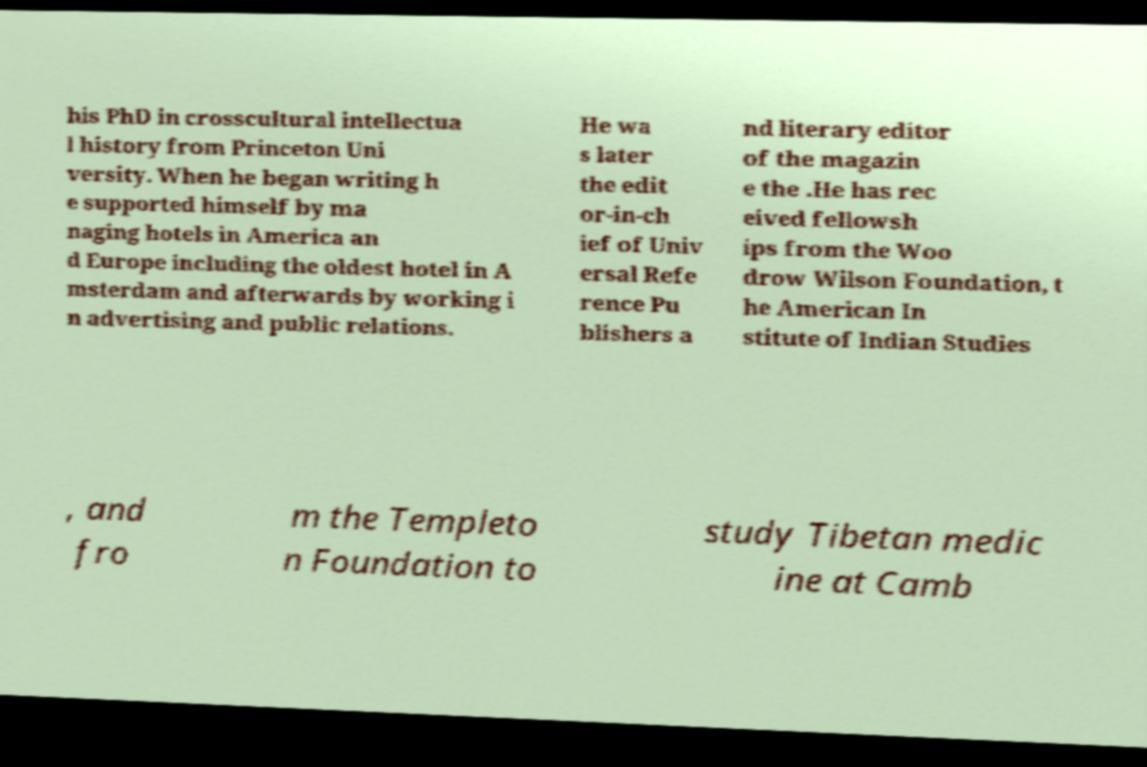For documentation purposes, I need the text within this image transcribed. Could you provide that? his PhD in crosscultural intellectua l history from Princeton Uni versity. When he began writing h e supported himself by ma naging hotels in America an d Europe including the oldest hotel in A msterdam and afterwards by working i n advertising and public relations. He wa s later the edit or-in-ch ief of Univ ersal Refe rence Pu blishers a nd literary editor of the magazin e the .He has rec eived fellowsh ips from the Woo drow Wilson Foundation, t he American In stitute of Indian Studies , and fro m the Templeto n Foundation to study Tibetan medic ine at Camb 